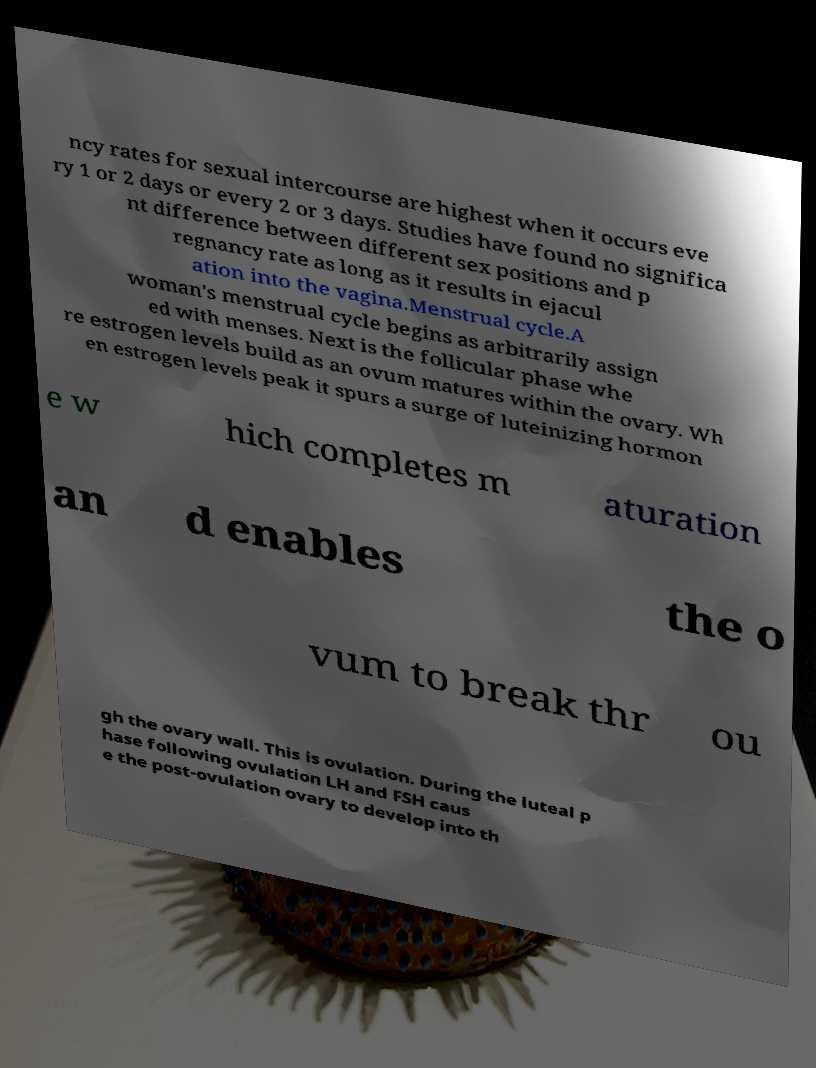For documentation purposes, I need the text within this image transcribed. Could you provide that? ncy rates for sexual intercourse are highest when it occurs eve ry 1 or 2 days or every 2 or 3 days. Studies have found no significa nt difference between different sex positions and p regnancy rate as long as it results in ejacul ation into the vagina.Menstrual cycle.A woman's menstrual cycle begins as arbitrarily assign ed with menses. Next is the follicular phase whe re estrogen levels build as an ovum matures within the ovary. Wh en estrogen levels peak it spurs a surge of luteinizing hormon e w hich completes m aturation an d enables the o vum to break thr ou gh the ovary wall. This is ovulation. During the luteal p hase following ovulation LH and FSH caus e the post-ovulation ovary to develop into th 